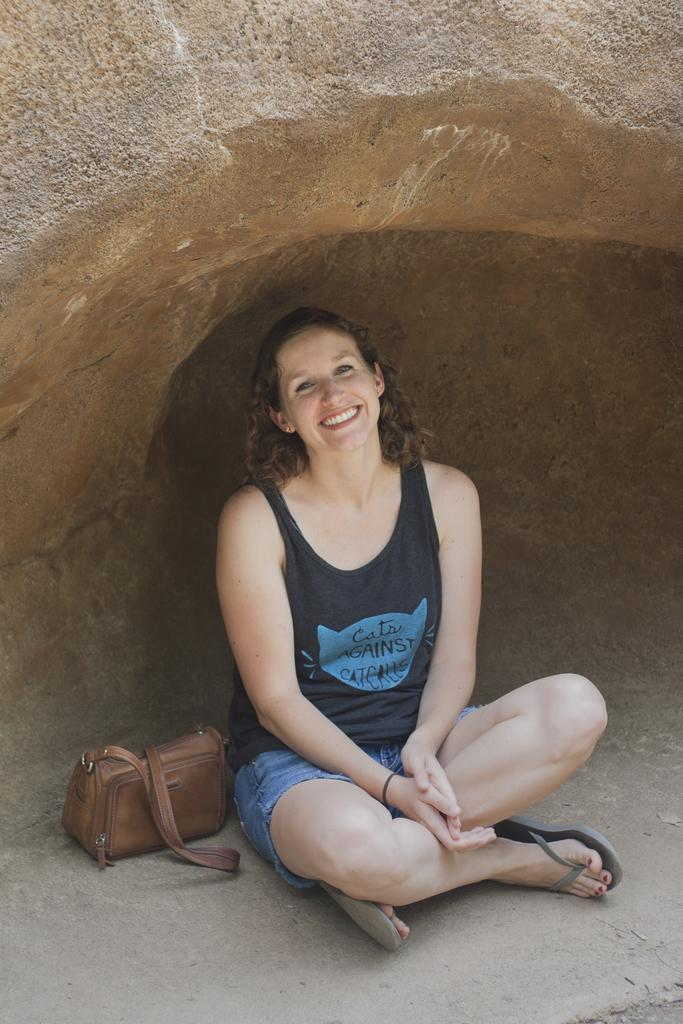Who is present in the image? There is a woman in the image. What is the woman doing in the image? The woman is sitting on the floor. What is the woman's facial expression in the image? The woman is smiling. What else can be seen in the image? There is a bag in the image. Can you tell me how many pairs of shoes are visible in the image? There are no shoes visible in the image. 